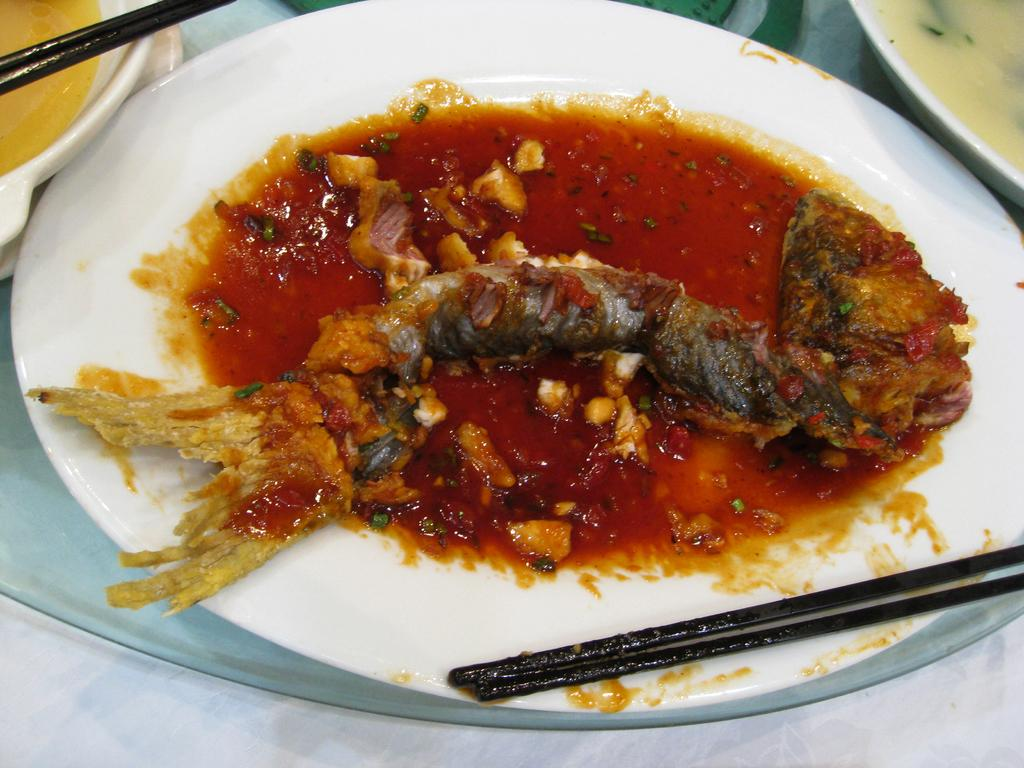What is on the plate that is visible in the image? The plate contains fish curry. What utensils are placed near the plate? There are chopsticks beside the plate. What month is it in the image? The image does not provide any information about the month or time of year. How many elbows can be seen in the image? There are no elbows visible in the image. 